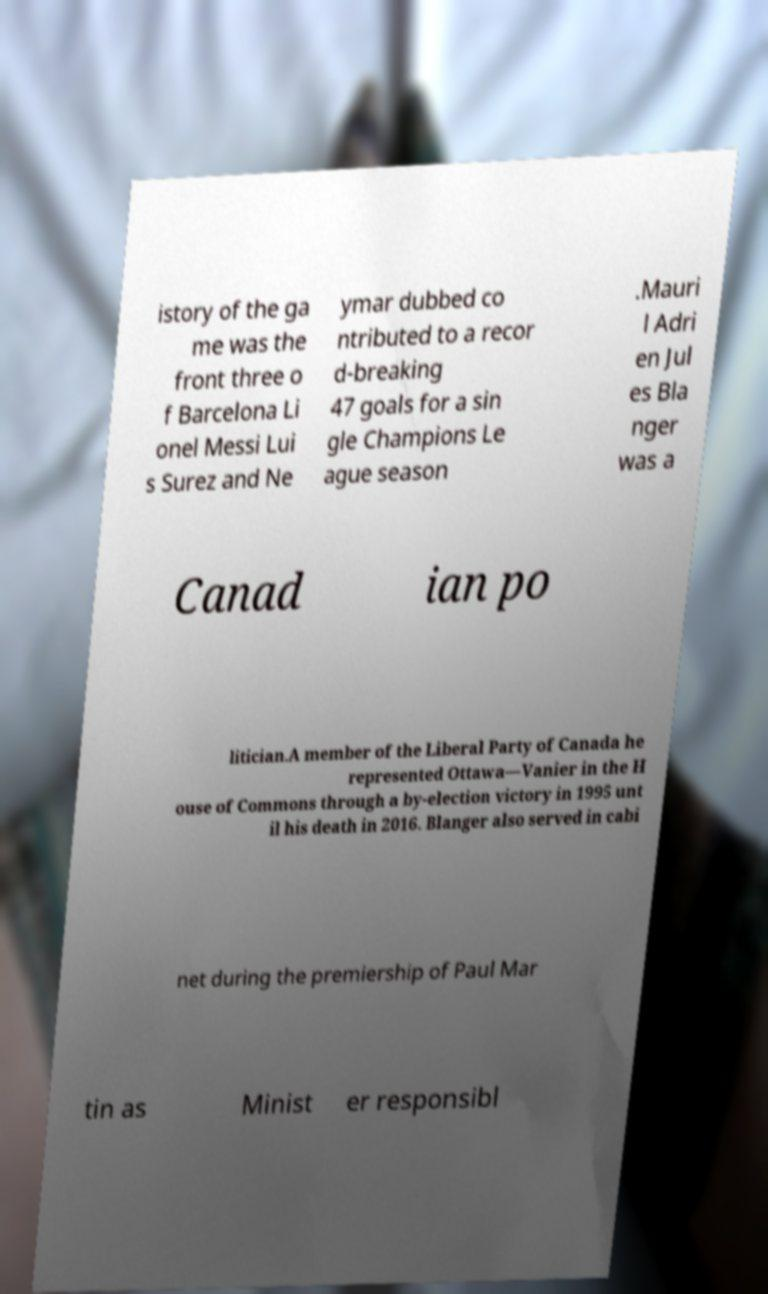There's text embedded in this image that I need extracted. Can you transcribe it verbatim? istory of the ga me was the front three o f Barcelona Li onel Messi Lui s Surez and Ne ymar dubbed co ntributed to a recor d-breaking 47 goals for a sin gle Champions Le ague season .Mauri l Adri en Jul es Bla nger was a Canad ian po litician.A member of the Liberal Party of Canada he represented Ottawa—Vanier in the H ouse of Commons through a by-election victory in 1995 unt il his death in 2016. Blanger also served in cabi net during the premiership of Paul Mar tin as Minist er responsibl 